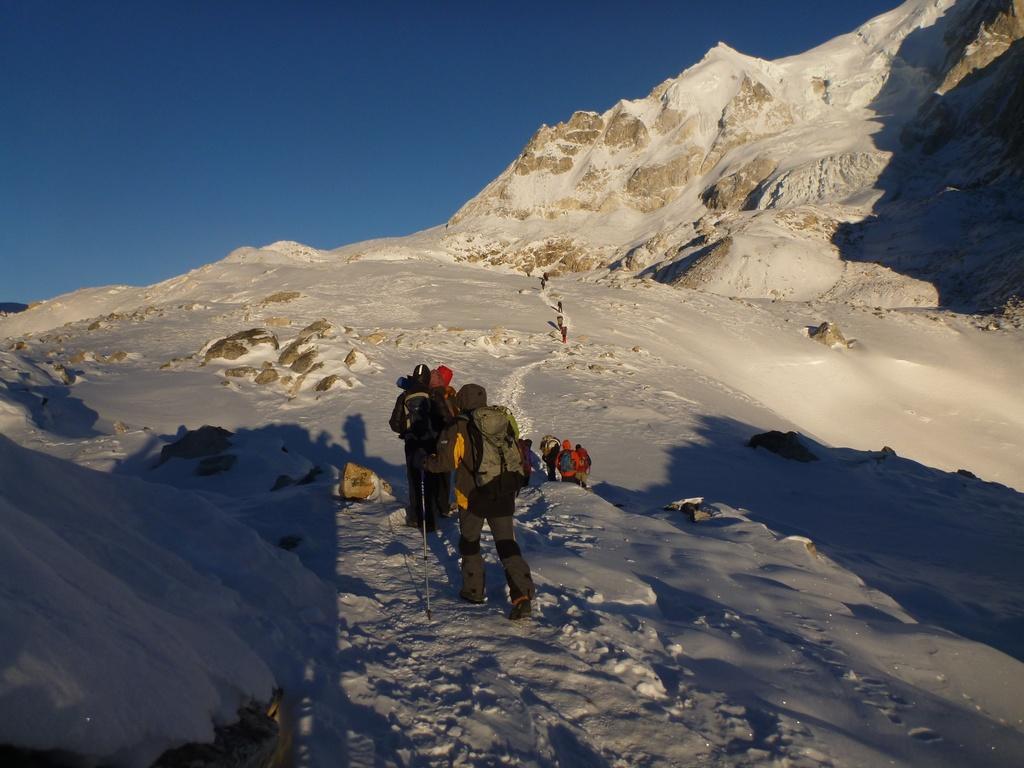How would you summarize this image in a sentence or two? In this image, we can see people and are wearing caps, coats and bags and one of them is holding a stick. In the background, we can see a mountain and at the bottom, there is snow and at the top, there is sky. 